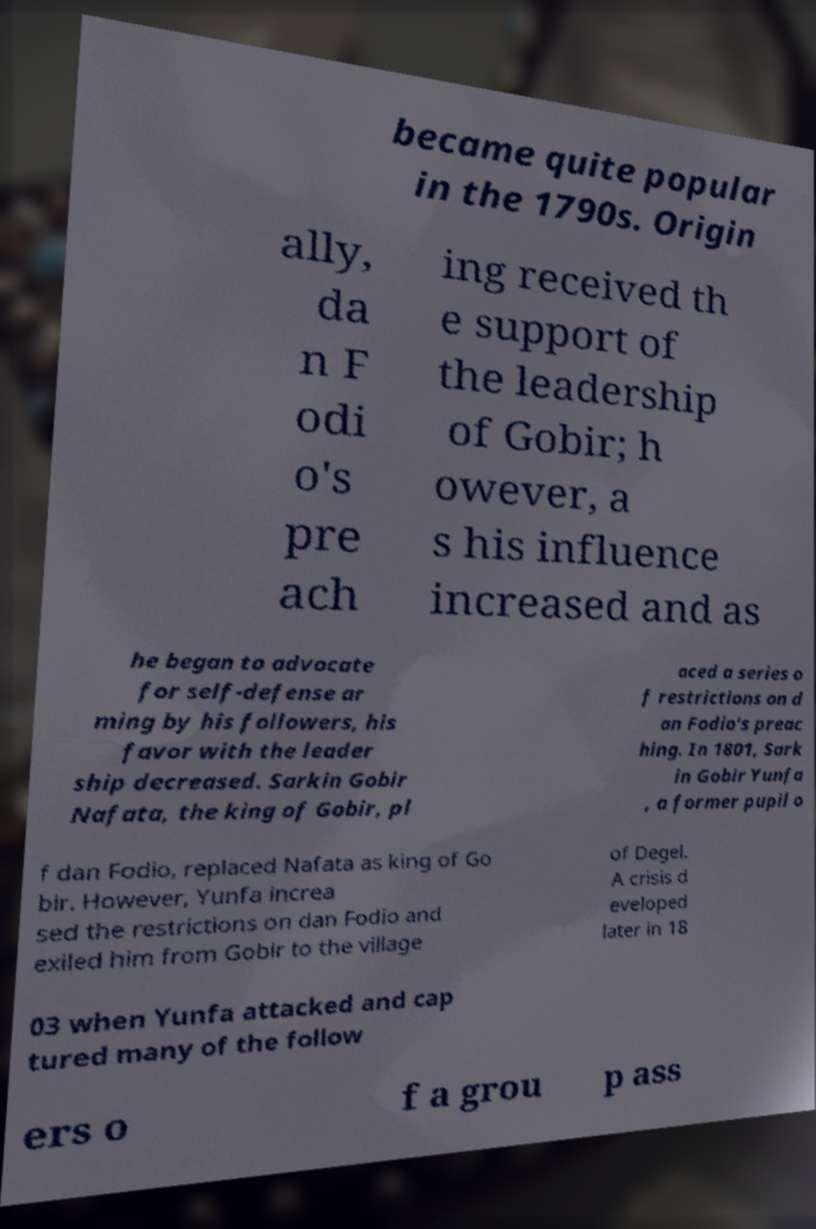Can you read and provide the text displayed in the image?This photo seems to have some interesting text. Can you extract and type it out for me? became quite popular in the 1790s. Origin ally, da n F odi o's pre ach ing received th e support of the leadership of Gobir; h owever, a s his influence increased and as he began to advocate for self-defense ar ming by his followers, his favor with the leader ship decreased. Sarkin Gobir Nafata, the king of Gobir, pl aced a series o f restrictions on d an Fodio's preac hing. In 1801, Sark in Gobir Yunfa , a former pupil o f dan Fodio, replaced Nafata as king of Go bir. However, Yunfa increa sed the restrictions on dan Fodio and exiled him from Gobir to the village of Degel. A crisis d eveloped later in 18 03 when Yunfa attacked and cap tured many of the follow ers o f a grou p ass 